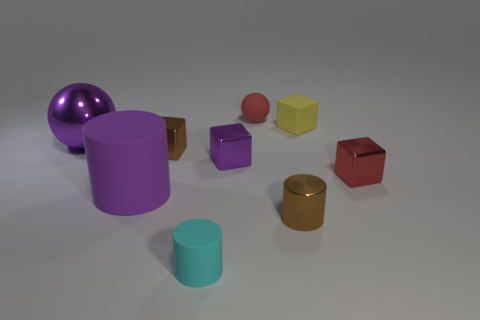Subtract all small cylinders. How many cylinders are left? 1 Subtract 2 cylinders. How many cylinders are left? 1 Add 1 tiny purple matte cylinders. How many objects exist? 10 Subtract all cylinders. How many objects are left? 6 Subtract all purple cylinders. How many cylinders are left? 2 Add 8 purple balls. How many purple balls exist? 9 Subtract 1 red balls. How many objects are left? 8 Subtract all green blocks. Subtract all green balls. How many blocks are left? 4 Subtract all green spheres. Subtract all red rubber things. How many objects are left? 8 Add 5 brown metal objects. How many brown metal objects are left? 7 